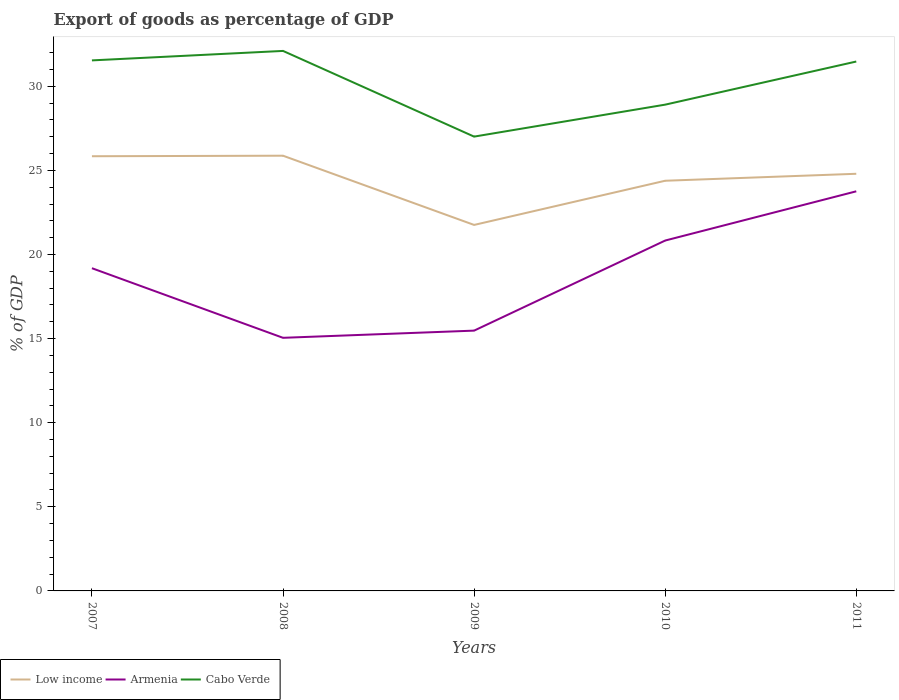Does the line corresponding to Armenia intersect with the line corresponding to Low income?
Your answer should be compact. No. Across all years, what is the maximum export of goods as percentage of GDP in Low income?
Give a very brief answer. 21.76. What is the total export of goods as percentage of GDP in Low income in the graph?
Your response must be concise. -2.63. What is the difference between the highest and the second highest export of goods as percentage of GDP in Low income?
Your answer should be very brief. 4.12. What is the difference between two consecutive major ticks on the Y-axis?
Your response must be concise. 5. Are the values on the major ticks of Y-axis written in scientific E-notation?
Your answer should be compact. No. Does the graph contain any zero values?
Offer a very short reply. No. Where does the legend appear in the graph?
Keep it short and to the point. Bottom left. How are the legend labels stacked?
Your answer should be compact. Horizontal. What is the title of the graph?
Keep it short and to the point. Export of goods as percentage of GDP. What is the label or title of the X-axis?
Provide a succinct answer. Years. What is the label or title of the Y-axis?
Give a very brief answer. % of GDP. What is the % of GDP in Low income in 2007?
Ensure brevity in your answer.  25.84. What is the % of GDP of Armenia in 2007?
Offer a terse response. 19.19. What is the % of GDP of Cabo Verde in 2007?
Your answer should be compact. 31.54. What is the % of GDP in Low income in 2008?
Your response must be concise. 25.87. What is the % of GDP in Armenia in 2008?
Provide a succinct answer. 15.05. What is the % of GDP of Cabo Verde in 2008?
Offer a very short reply. 32.1. What is the % of GDP of Low income in 2009?
Ensure brevity in your answer.  21.76. What is the % of GDP of Armenia in 2009?
Offer a very short reply. 15.47. What is the % of GDP of Cabo Verde in 2009?
Make the answer very short. 27.01. What is the % of GDP in Low income in 2010?
Provide a short and direct response. 24.38. What is the % of GDP of Armenia in 2010?
Ensure brevity in your answer.  20.83. What is the % of GDP in Cabo Verde in 2010?
Make the answer very short. 28.91. What is the % of GDP in Low income in 2011?
Your response must be concise. 24.8. What is the % of GDP of Armenia in 2011?
Provide a short and direct response. 23.76. What is the % of GDP in Cabo Verde in 2011?
Ensure brevity in your answer.  31.47. Across all years, what is the maximum % of GDP of Low income?
Give a very brief answer. 25.87. Across all years, what is the maximum % of GDP of Armenia?
Provide a short and direct response. 23.76. Across all years, what is the maximum % of GDP in Cabo Verde?
Offer a very short reply. 32.1. Across all years, what is the minimum % of GDP in Low income?
Ensure brevity in your answer.  21.76. Across all years, what is the minimum % of GDP of Armenia?
Your answer should be compact. 15.05. Across all years, what is the minimum % of GDP in Cabo Verde?
Provide a short and direct response. 27.01. What is the total % of GDP of Low income in the graph?
Your response must be concise. 122.66. What is the total % of GDP of Armenia in the graph?
Keep it short and to the point. 94.29. What is the total % of GDP of Cabo Verde in the graph?
Provide a succinct answer. 151.03. What is the difference between the % of GDP in Low income in 2007 and that in 2008?
Ensure brevity in your answer.  -0.03. What is the difference between the % of GDP of Armenia in 2007 and that in 2008?
Your response must be concise. 4.14. What is the difference between the % of GDP in Cabo Verde in 2007 and that in 2008?
Keep it short and to the point. -0.56. What is the difference between the % of GDP of Low income in 2007 and that in 2009?
Offer a very short reply. 4.08. What is the difference between the % of GDP of Armenia in 2007 and that in 2009?
Your answer should be very brief. 3.71. What is the difference between the % of GDP of Cabo Verde in 2007 and that in 2009?
Keep it short and to the point. 4.53. What is the difference between the % of GDP of Low income in 2007 and that in 2010?
Provide a succinct answer. 1.46. What is the difference between the % of GDP of Armenia in 2007 and that in 2010?
Offer a very short reply. -1.64. What is the difference between the % of GDP in Cabo Verde in 2007 and that in 2010?
Your response must be concise. 2.63. What is the difference between the % of GDP of Low income in 2007 and that in 2011?
Keep it short and to the point. 1.04. What is the difference between the % of GDP of Armenia in 2007 and that in 2011?
Your response must be concise. -4.57. What is the difference between the % of GDP in Cabo Verde in 2007 and that in 2011?
Provide a short and direct response. 0.07. What is the difference between the % of GDP in Low income in 2008 and that in 2009?
Provide a short and direct response. 4.12. What is the difference between the % of GDP in Armenia in 2008 and that in 2009?
Make the answer very short. -0.43. What is the difference between the % of GDP of Cabo Verde in 2008 and that in 2009?
Offer a terse response. 5.09. What is the difference between the % of GDP in Low income in 2008 and that in 2010?
Keep it short and to the point. 1.49. What is the difference between the % of GDP of Armenia in 2008 and that in 2010?
Keep it short and to the point. -5.78. What is the difference between the % of GDP of Cabo Verde in 2008 and that in 2010?
Give a very brief answer. 3.19. What is the difference between the % of GDP in Low income in 2008 and that in 2011?
Make the answer very short. 1.07. What is the difference between the % of GDP of Armenia in 2008 and that in 2011?
Keep it short and to the point. -8.71. What is the difference between the % of GDP of Cabo Verde in 2008 and that in 2011?
Ensure brevity in your answer.  0.63. What is the difference between the % of GDP in Low income in 2009 and that in 2010?
Provide a short and direct response. -2.63. What is the difference between the % of GDP of Armenia in 2009 and that in 2010?
Keep it short and to the point. -5.36. What is the difference between the % of GDP of Cabo Verde in 2009 and that in 2010?
Your response must be concise. -1.9. What is the difference between the % of GDP of Low income in 2009 and that in 2011?
Make the answer very short. -3.04. What is the difference between the % of GDP in Armenia in 2009 and that in 2011?
Your answer should be very brief. -8.28. What is the difference between the % of GDP in Cabo Verde in 2009 and that in 2011?
Your answer should be very brief. -4.46. What is the difference between the % of GDP in Low income in 2010 and that in 2011?
Keep it short and to the point. -0.41. What is the difference between the % of GDP in Armenia in 2010 and that in 2011?
Your answer should be very brief. -2.93. What is the difference between the % of GDP of Cabo Verde in 2010 and that in 2011?
Your answer should be very brief. -2.56. What is the difference between the % of GDP of Low income in 2007 and the % of GDP of Armenia in 2008?
Your answer should be very brief. 10.8. What is the difference between the % of GDP of Low income in 2007 and the % of GDP of Cabo Verde in 2008?
Provide a short and direct response. -6.26. What is the difference between the % of GDP of Armenia in 2007 and the % of GDP of Cabo Verde in 2008?
Your answer should be very brief. -12.92. What is the difference between the % of GDP in Low income in 2007 and the % of GDP in Armenia in 2009?
Make the answer very short. 10.37. What is the difference between the % of GDP of Low income in 2007 and the % of GDP of Cabo Verde in 2009?
Provide a short and direct response. -1.17. What is the difference between the % of GDP in Armenia in 2007 and the % of GDP in Cabo Verde in 2009?
Make the answer very short. -7.82. What is the difference between the % of GDP in Low income in 2007 and the % of GDP in Armenia in 2010?
Provide a succinct answer. 5.01. What is the difference between the % of GDP in Low income in 2007 and the % of GDP in Cabo Verde in 2010?
Offer a very short reply. -3.07. What is the difference between the % of GDP of Armenia in 2007 and the % of GDP of Cabo Verde in 2010?
Offer a terse response. -9.72. What is the difference between the % of GDP of Low income in 2007 and the % of GDP of Armenia in 2011?
Ensure brevity in your answer.  2.09. What is the difference between the % of GDP of Low income in 2007 and the % of GDP of Cabo Verde in 2011?
Offer a terse response. -5.63. What is the difference between the % of GDP in Armenia in 2007 and the % of GDP in Cabo Verde in 2011?
Offer a very short reply. -12.29. What is the difference between the % of GDP of Low income in 2008 and the % of GDP of Armenia in 2009?
Offer a very short reply. 10.4. What is the difference between the % of GDP of Low income in 2008 and the % of GDP of Cabo Verde in 2009?
Your response must be concise. -1.14. What is the difference between the % of GDP in Armenia in 2008 and the % of GDP in Cabo Verde in 2009?
Your answer should be very brief. -11.96. What is the difference between the % of GDP in Low income in 2008 and the % of GDP in Armenia in 2010?
Ensure brevity in your answer.  5.04. What is the difference between the % of GDP in Low income in 2008 and the % of GDP in Cabo Verde in 2010?
Provide a short and direct response. -3.04. What is the difference between the % of GDP of Armenia in 2008 and the % of GDP of Cabo Verde in 2010?
Your answer should be very brief. -13.86. What is the difference between the % of GDP in Low income in 2008 and the % of GDP in Armenia in 2011?
Make the answer very short. 2.12. What is the difference between the % of GDP in Low income in 2008 and the % of GDP in Cabo Verde in 2011?
Ensure brevity in your answer.  -5.6. What is the difference between the % of GDP of Armenia in 2008 and the % of GDP of Cabo Verde in 2011?
Provide a short and direct response. -16.43. What is the difference between the % of GDP in Low income in 2009 and the % of GDP in Armenia in 2010?
Provide a succinct answer. 0.93. What is the difference between the % of GDP in Low income in 2009 and the % of GDP in Cabo Verde in 2010?
Provide a succinct answer. -7.15. What is the difference between the % of GDP of Armenia in 2009 and the % of GDP of Cabo Verde in 2010?
Your response must be concise. -13.43. What is the difference between the % of GDP of Low income in 2009 and the % of GDP of Armenia in 2011?
Make the answer very short. -2. What is the difference between the % of GDP of Low income in 2009 and the % of GDP of Cabo Verde in 2011?
Your answer should be compact. -9.71. What is the difference between the % of GDP in Armenia in 2009 and the % of GDP in Cabo Verde in 2011?
Your answer should be compact. -16. What is the difference between the % of GDP in Low income in 2010 and the % of GDP in Armenia in 2011?
Provide a succinct answer. 0.63. What is the difference between the % of GDP in Low income in 2010 and the % of GDP in Cabo Verde in 2011?
Offer a very short reply. -7.09. What is the difference between the % of GDP of Armenia in 2010 and the % of GDP of Cabo Verde in 2011?
Your answer should be very brief. -10.64. What is the average % of GDP in Low income per year?
Ensure brevity in your answer.  24.53. What is the average % of GDP in Armenia per year?
Provide a short and direct response. 18.86. What is the average % of GDP in Cabo Verde per year?
Provide a succinct answer. 30.21. In the year 2007, what is the difference between the % of GDP in Low income and % of GDP in Armenia?
Provide a short and direct response. 6.66. In the year 2007, what is the difference between the % of GDP of Low income and % of GDP of Cabo Verde?
Ensure brevity in your answer.  -5.7. In the year 2007, what is the difference between the % of GDP of Armenia and % of GDP of Cabo Verde?
Offer a very short reply. -12.35. In the year 2008, what is the difference between the % of GDP in Low income and % of GDP in Armenia?
Your answer should be very brief. 10.83. In the year 2008, what is the difference between the % of GDP in Low income and % of GDP in Cabo Verde?
Make the answer very short. -6.23. In the year 2008, what is the difference between the % of GDP of Armenia and % of GDP of Cabo Verde?
Your response must be concise. -17.06. In the year 2009, what is the difference between the % of GDP of Low income and % of GDP of Armenia?
Make the answer very short. 6.28. In the year 2009, what is the difference between the % of GDP in Low income and % of GDP in Cabo Verde?
Provide a short and direct response. -5.25. In the year 2009, what is the difference between the % of GDP in Armenia and % of GDP in Cabo Verde?
Provide a succinct answer. -11.53. In the year 2010, what is the difference between the % of GDP in Low income and % of GDP in Armenia?
Your answer should be compact. 3.55. In the year 2010, what is the difference between the % of GDP in Low income and % of GDP in Cabo Verde?
Keep it short and to the point. -4.52. In the year 2010, what is the difference between the % of GDP of Armenia and % of GDP of Cabo Verde?
Provide a short and direct response. -8.08. In the year 2011, what is the difference between the % of GDP in Low income and % of GDP in Armenia?
Ensure brevity in your answer.  1.04. In the year 2011, what is the difference between the % of GDP in Low income and % of GDP in Cabo Verde?
Your response must be concise. -6.67. In the year 2011, what is the difference between the % of GDP in Armenia and % of GDP in Cabo Verde?
Offer a terse response. -7.72. What is the ratio of the % of GDP in Low income in 2007 to that in 2008?
Make the answer very short. 1. What is the ratio of the % of GDP in Armenia in 2007 to that in 2008?
Your answer should be compact. 1.27. What is the ratio of the % of GDP in Cabo Verde in 2007 to that in 2008?
Make the answer very short. 0.98. What is the ratio of the % of GDP of Low income in 2007 to that in 2009?
Offer a very short reply. 1.19. What is the ratio of the % of GDP of Armenia in 2007 to that in 2009?
Ensure brevity in your answer.  1.24. What is the ratio of the % of GDP in Cabo Verde in 2007 to that in 2009?
Make the answer very short. 1.17. What is the ratio of the % of GDP of Low income in 2007 to that in 2010?
Your answer should be compact. 1.06. What is the ratio of the % of GDP in Armenia in 2007 to that in 2010?
Offer a terse response. 0.92. What is the ratio of the % of GDP in Cabo Verde in 2007 to that in 2010?
Offer a terse response. 1.09. What is the ratio of the % of GDP in Low income in 2007 to that in 2011?
Your response must be concise. 1.04. What is the ratio of the % of GDP of Armenia in 2007 to that in 2011?
Keep it short and to the point. 0.81. What is the ratio of the % of GDP of Low income in 2008 to that in 2009?
Provide a succinct answer. 1.19. What is the ratio of the % of GDP in Armenia in 2008 to that in 2009?
Keep it short and to the point. 0.97. What is the ratio of the % of GDP of Cabo Verde in 2008 to that in 2009?
Your answer should be compact. 1.19. What is the ratio of the % of GDP of Low income in 2008 to that in 2010?
Give a very brief answer. 1.06. What is the ratio of the % of GDP in Armenia in 2008 to that in 2010?
Your response must be concise. 0.72. What is the ratio of the % of GDP of Cabo Verde in 2008 to that in 2010?
Ensure brevity in your answer.  1.11. What is the ratio of the % of GDP in Low income in 2008 to that in 2011?
Your answer should be very brief. 1.04. What is the ratio of the % of GDP in Armenia in 2008 to that in 2011?
Provide a short and direct response. 0.63. What is the ratio of the % of GDP of Cabo Verde in 2008 to that in 2011?
Your response must be concise. 1.02. What is the ratio of the % of GDP of Low income in 2009 to that in 2010?
Make the answer very short. 0.89. What is the ratio of the % of GDP in Armenia in 2009 to that in 2010?
Provide a short and direct response. 0.74. What is the ratio of the % of GDP in Cabo Verde in 2009 to that in 2010?
Your response must be concise. 0.93. What is the ratio of the % of GDP in Low income in 2009 to that in 2011?
Make the answer very short. 0.88. What is the ratio of the % of GDP of Armenia in 2009 to that in 2011?
Ensure brevity in your answer.  0.65. What is the ratio of the % of GDP in Cabo Verde in 2009 to that in 2011?
Ensure brevity in your answer.  0.86. What is the ratio of the % of GDP of Low income in 2010 to that in 2011?
Give a very brief answer. 0.98. What is the ratio of the % of GDP of Armenia in 2010 to that in 2011?
Provide a short and direct response. 0.88. What is the ratio of the % of GDP in Cabo Verde in 2010 to that in 2011?
Offer a very short reply. 0.92. What is the difference between the highest and the second highest % of GDP in Low income?
Offer a terse response. 0.03. What is the difference between the highest and the second highest % of GDP in Armenia?
Your answer should be compact. 2.93. What is the difference between the highest and the second highest % of GDP of Cabo Verde?
Ensure brevity in your answer.  0.56. What is the difference between the highest and the lowest % of GDP in Low income?
Give a very brief answer. 4.12. What is the difference between the highest and the lowest % of GDP in Armenia?
Offer a very short reply. 8.71. What is the difference between the highest and the lowest % of GDP of Cabo Verde?
Make the answer very short. 5.09. 